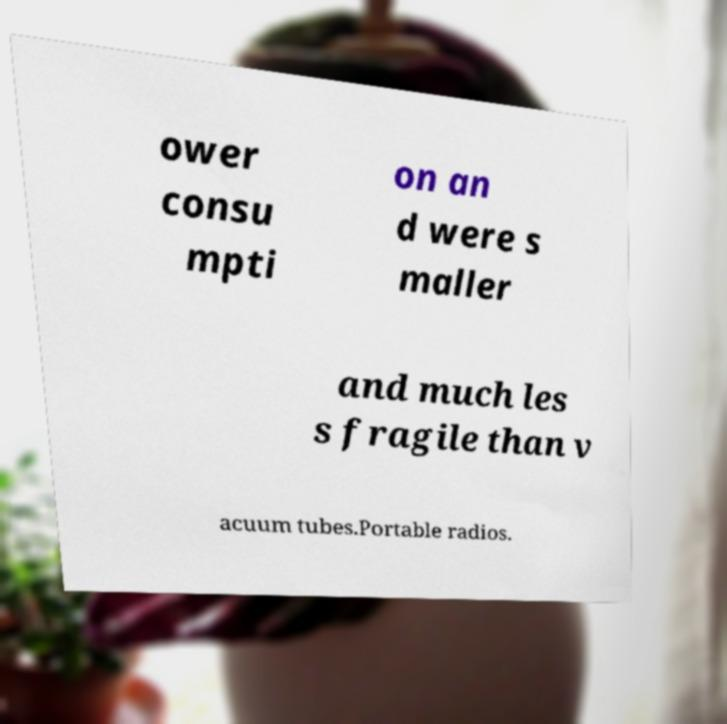Please identify and transcribe the text found in this image. ower consu mpti on an d were s maller and much les s fragile than v acuum tubes.Portable radios. 